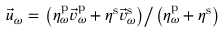<formula> <loc_0><loc_0><loc_500><loc_500>\vec { u } _ { \omega } = \left ( \eta _ { \omega } ^ { p } \vec { v } _ { \omega } ^ { p } + \eta ^ { s } \vec { v } _ { \omega } ^ { s } \right ) \right / \left ( \eta _ { \omega } ^ { p } + \eta ^ { s } \right )</formula> 